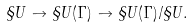Convert formula to latex. <formula><loc_0><loc_0><loc_500><loc_500>\S U \to \S U ( \Gamma ) \to \S U ( \Gamma ) / \S U .</formula> 